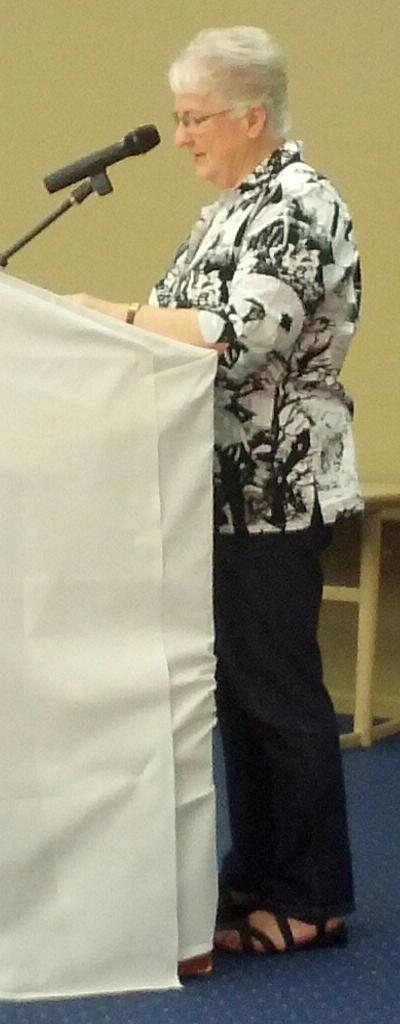Could you give a brief overview of what you see in this image? This image is taken indoors. At the bottom of the image there is a floor. In the background there is a wall and a table. In the middle of the image a woman is standing on the floor near the podium and talking on a mic. 